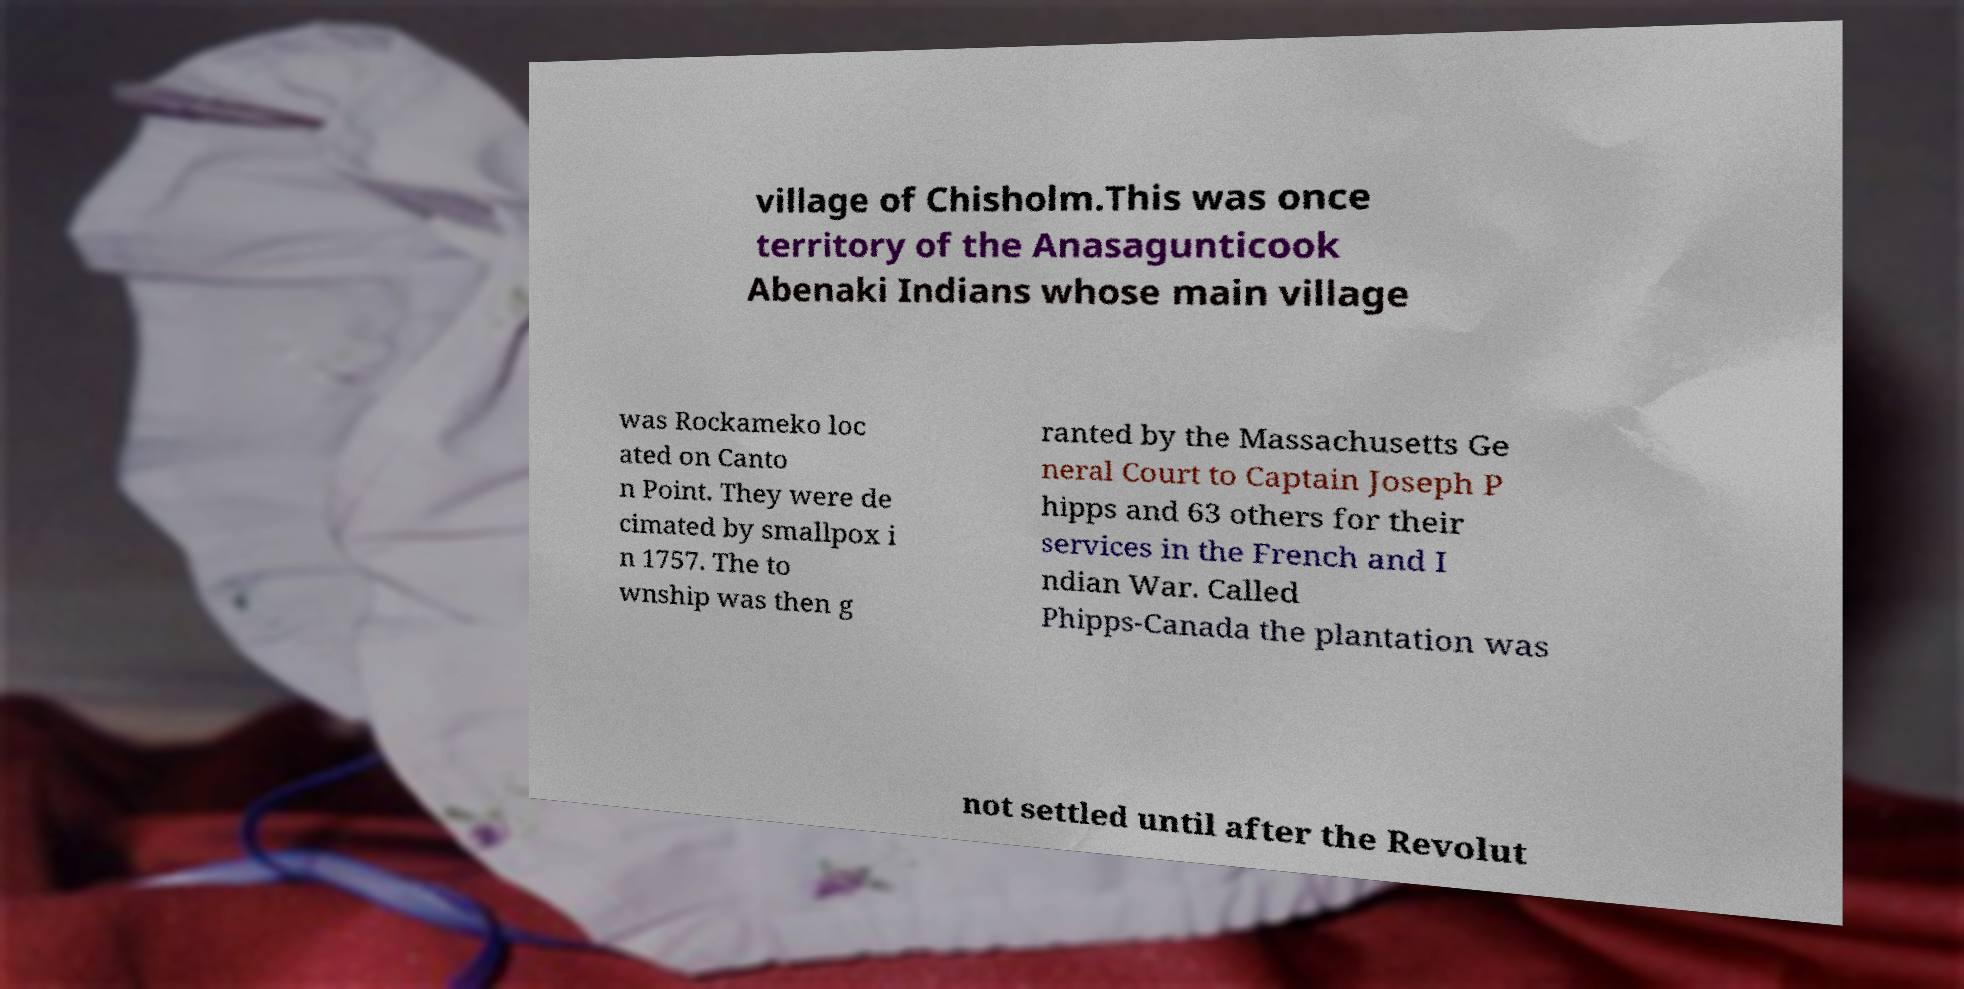There's text embedded in this image that I need extracted. Can you transcribe it verbatim? village of Chisholm.This was once territory of the Anasagunticook Abenaki Indians whose main village was Rockameko loc ated on Canto n Point. They were de cimated by smallpox i n 1757. The to wnship was then g ranted by the Massachusetts Ge neral Court to Captain Joseph P hipps and 63 others for their services in the French and I ndian War. Called Phipps-Canada the plantation was not settled until after the Revolut 